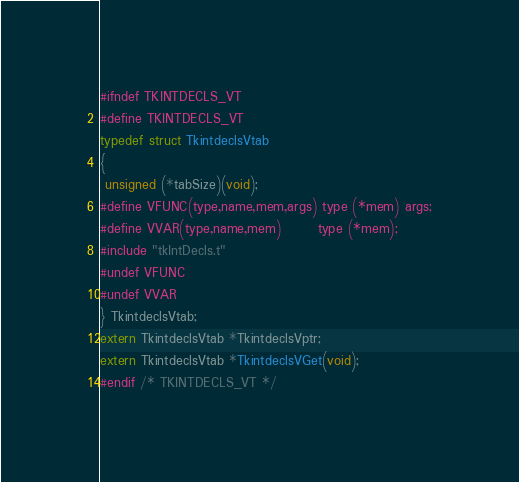<code> <loc_0><loc_0><loc_500><loc_500><_C_>#ifndef TKINTDECLS_VT
#define TKINTDECLS_VT
typedef struct TkintdeclsVtab
{
 unsigned (*tabSize)(void);
#define VFUNC(type,name,mem,args) type (*mem) args;
#define VVAR(type,name,mem)       type (*mem);
#include "tkIntDecls.t"
#undef VFUNC
#undef VVAR
} TkintdeclsVtab;
extern TkintdeclsVtab *TkintdeclsVptr;
extern TkintdeclsVtab *TkintdeclsVGet(void);
#endif /* TKINTDECLS_VT */
</code> 